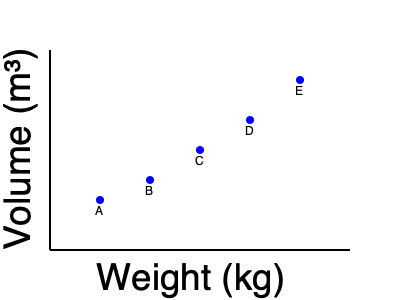As a furniture importer, you're analyzing shipping costs based on weight and volume. The scatter plot shows five furniture items (A, B, C, D, E) with their respective weights and volumes. If the shipping cost is calculated as $\$10$ per kg of weight plus $\$50$ per m³ of volume, which item would be the most expensive to ship? Assume the weight of item C is 75 kg and its volume is 2 m³. To determine the most expensive item to ship, we need to calculate the shipping cost for each item. We're given the information for item C, so let's start with that and use it as a reference to estimate the values for other items.

1. Calculate the cost for item C:
   Weight cost: $75 \text{ kg} \times \$10/\text{kg} = \$750$
   Volume cost: $2 \text{ m}^3 \times \$50/\text{m}^3 = \$100$
   Total cost for C: $\$750 + \$100 = \$850$

2. Estimate values and calculate costs for other items:
   A: Weight ≈ 50 kg, Volume ≈ 1 m³
      Cost = $(50 \times \$10) + (1 \times \$50) = \$500 + \$50 = \$550$
   
   B: Weight ≈ 62.5 kg, Volume ≈ 1.5 m³
      Cost = $(62.5 \times \$10) + (1.5 \times \$50) = \$625 + \$75 = \$700$
   
   D: Weight ≈ 87.5 kg, Volume ≈ 2.5 m³
      Cost = $(87.5 \times \$10) + (2.5 \times \$50) = \$875 + \$125 = \$1000$
   
   E: Weight ≈ 100 kg, Volume ≈ 3 m³
      Cost = $(100 \times \$10) + (3 \times \$50) = \$1000 + \$150 = \$1150$

3. Compare the costs:
   A: $\$550$
   B: $\$700$
   C: $\$850$
   D: $\$1000$
   E: $\$1150$

Therefore, item E would be the most expensive to ship.
Answer: Item E 